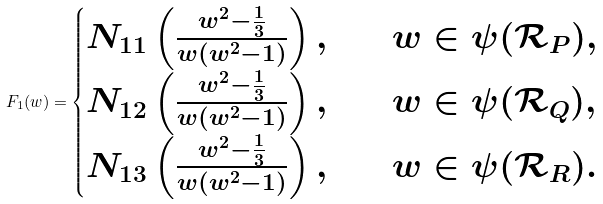<formula> <loc_0><loc_0><loc_500><loc_500>F _ { 1 } ( w ) = \begin{cases} N _ { 1 1 } \left ( \frac { w ^ { 2 } - \frac { 1 } { 3 } } { w ( w ^ { 2 } - 1 ) } \right ) , & \quad w \in \psi ( \mathcal { R } _ { P } ) , \\ N _ { 1 2 } \left ( \frac { w ^ { 2 } - \frac { 1 } { 3 } } { w ( w ^ { 2 } - 1 ) } \right ) , & \quad w \in \psi ( \mathcal { R } _ { Q } ) , \\ N _ { 1 3 } \left ( \frac { w ^ { 2 } - \frac { 1 } { 3 } } { w ( w ^ { 2 } - 1 ) } \right ) , & \quad w \in \psi ( \mathcal { R } _ { R } ) . \end{cases}</formula> 